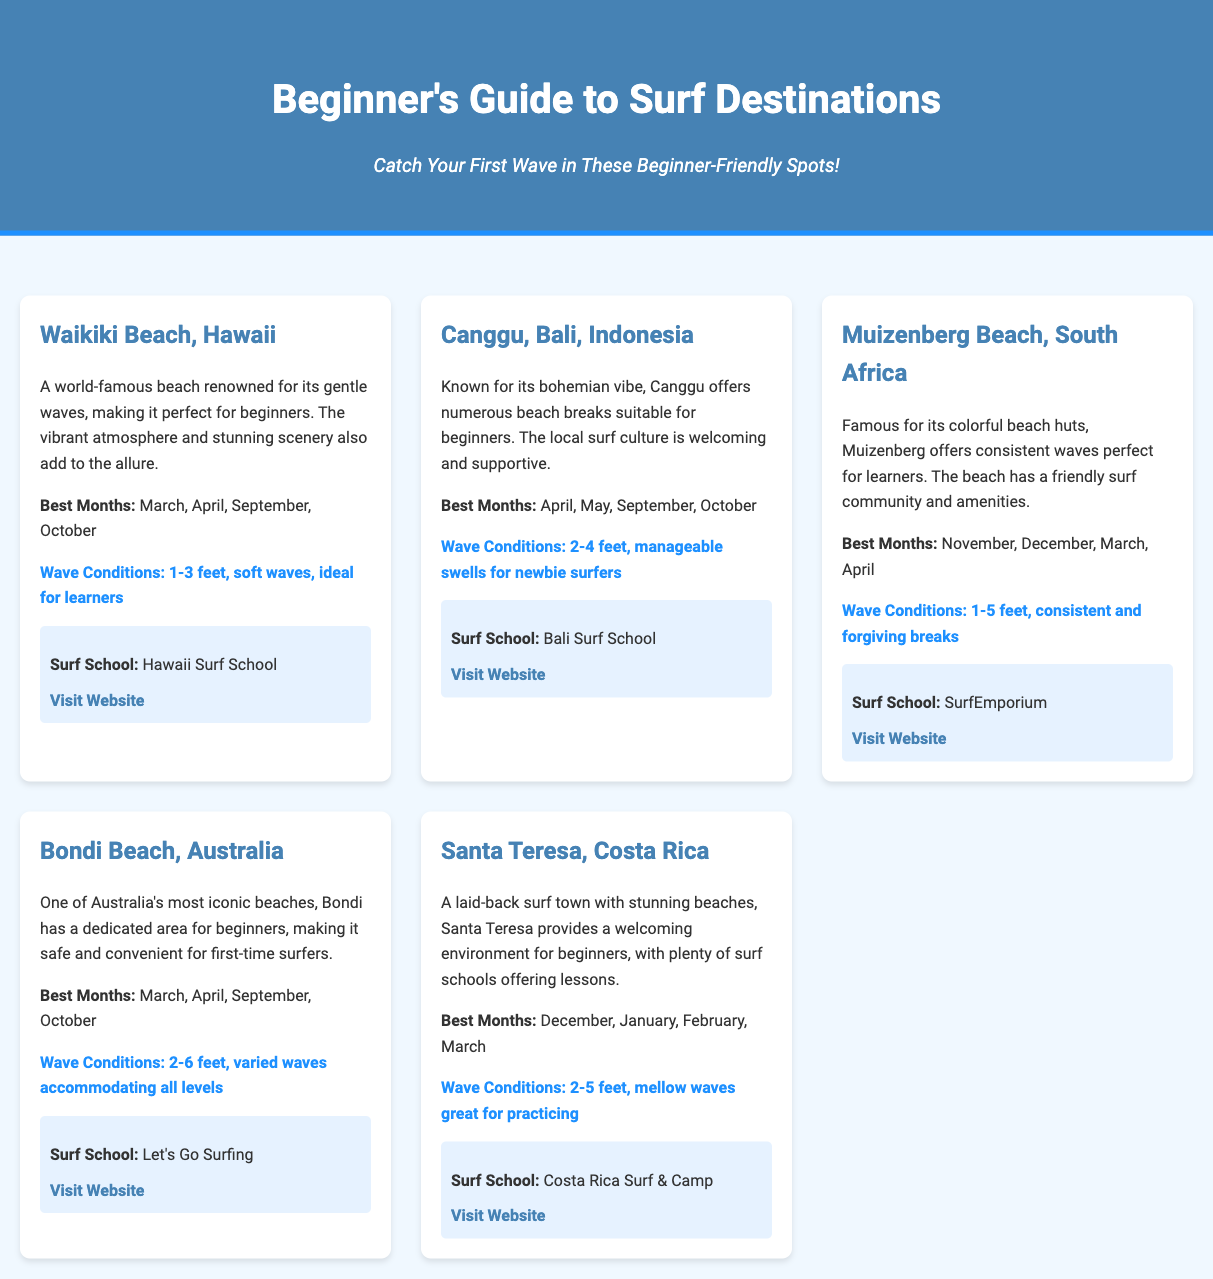What is the best month to surf at Waikiki Beach? The document states that the best months to surf at Waikiki Beach are March, April, September, and October.
Answer: March, April, September, October What is the wave condition at Canggu, Bali? The wave conditions at Canggu, Bali, are described as 2-4 feet, manageable swells for newbie surfers.
Answer: 2-4 feet What surf school is mentioned for Muizenberg Beach? The surf school mentioned for Muizenberg Beach is SurfEmporium.
Answer: SurfEmporium Which destination has a beginner area specifically mentioned? Bondi Beach is described as having a dedicated area for beginners.
Answer: Bondi Beach What is the wave condition range at Santa Teresa, Costa Rica? The wave conditions at Santa Teresa, Costa Rica, are 2-5 feet, mellow waves great for practicing.
Answer: 2-5 feet Which surf school can be found on Waikiki Beach? Hawaii Surf School is the surf school available at Waikiki Beach.
Answer: Hawaii Surf School What is a unique feature of Muizenberg Beach? Muizenberg Beach is famous for its colorful beach huts.
Answer: Colorful beach huts In which destination can you find a welcoming surf community? Muizenberg Beach, South Africa, is noted for having a friendly surf community.
Answer: Muizenberg Beach 